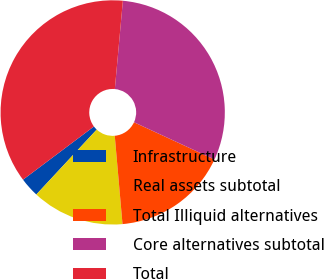Convert chart. <chart><loc_0><loc_0><loc_500><loc_500><pie_chart><fcel>Infrastructure<fcel>Real assets subtotal<fcel>Total Illiquid alternatives<fcel>Core alternatives subtotal<fcel>Total<nl><fcel>2.83%<fcel>13.32%<fcel>16.71%<fcel>30.45%<fcel>36.69%<nl></chart> 